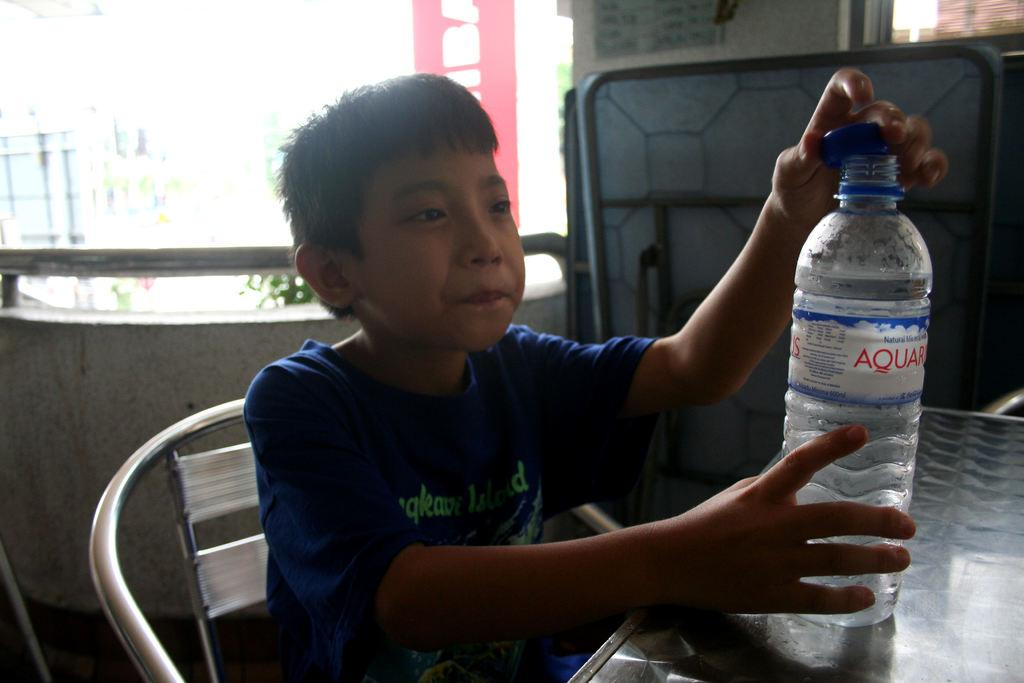Who is the main subject in the image? There is a boy in the image. What is the boy doing in the image? The boy is sitting on a chair. Where is the chair located in relation to the table? The chair is in front of a table. What is the boy holding in the image? The boy is holding a bottle. Where is the bottle when it is not being held by the boy? The bottle is on the table. What type of waves can be seen in the image? There are no waves present in the image. What order is the boy following in the image? There is no specific order being followed in the image. 